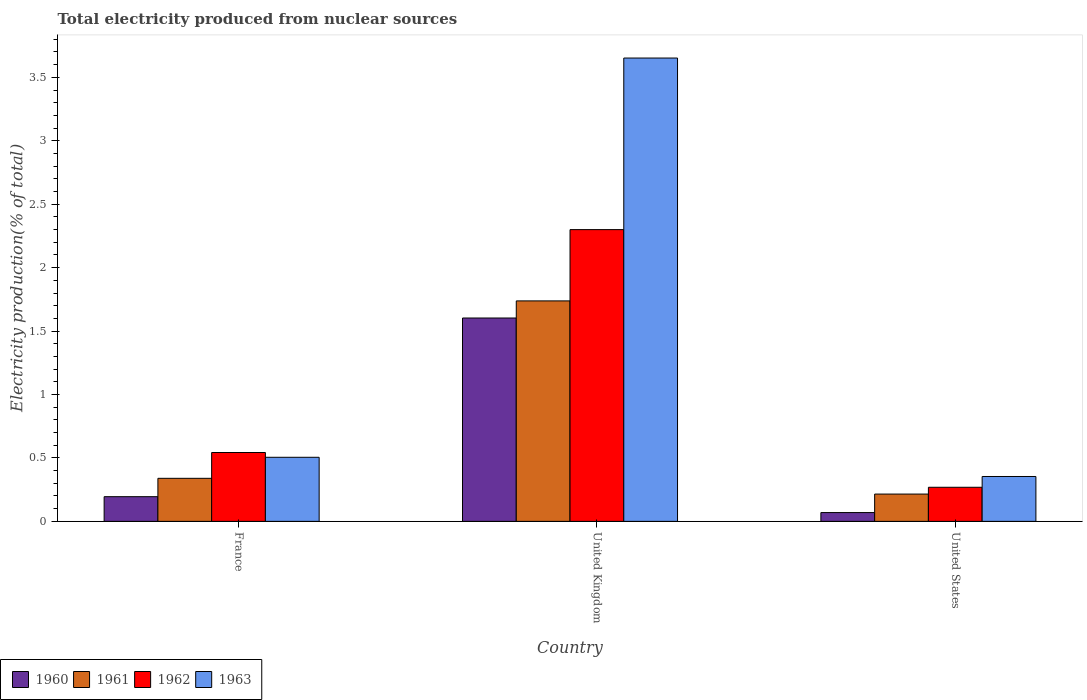How many bars are there on the 3rd tick from the left?
Make the answer very short. 4. In how many cases, is the number of bars for a given country not equal to the number of legend labels?
Provide a short and direct response. 0. What is the total electricity produced in 1960 in France?
Your answer should be compact. 0.19. Across all countries, what is the maximum total electricity produced in 1962?
Give a very brief answer. 2.3. Across all countries, what is the minimum total electricity produced in 1963?
Keep it short and to the point. 0.35. In which country was the total electricity produced in 1963 maximum?
Offer a very short reply. United Kingdom. In which country was the total electricity produced in 1962 minimum?
Make the answer very short. United States. What is the total total electricity produced in 1963 in the graph?
Ensure brevity in your answer.  4.51. What is the difference between the total electricity produced in 1962 in United Kingdom and that in United States?
Give a very brief answer. 2.03. What is the difference between the total electricity produced in 1960 in France and the total electricity produced in 1962 in United Kingdom?
Offer a terse response. -2.11. What is the average total electricity produced in 1960 per country?
Offer a terse response. 0.62. What is the difference between the total electricity produced of/in 1961 and total electricity produced of/in 1962 in France?
Offer a very short reply. -0.2. What is the ratio of the total electricity produced in 1960 in United Kingdom to that in United States?
Your answer should be compact. 23.14. Is the total electricity produced in 1960 in France less than that in United States?
Offer a very short reply. No. What is the difference between the highest and the second highest total electricity produced in 1963?
Give a very brief answer. -3.15. What is the difference between the highest and the lowest total electricity produced in 1960?
Your answer should be compact. 1.53. Is it the case that in every country, the sum of the total electricity produced in 1962 and total electricity produced in 1961 is greater than the sum of total electricity produced in 1960 and total electricity produced in 1963?
Your response must be concise. No. What does the 2nd bar from the left in United States represents?
Your response must be concise. 1961. What does the 1st bar from the right in United States represents?
Provide a succinct answer. 1963. Is it the case that in every country, the sum of the total electricity produced in 1962 and total electricity produced in 1963 is greater than the total electricity produced in 1961?
Ensure brevity in your answer.  Yes. Are all the bars in the graph horizontal?
Provide a succinct answer. No. Are the values on the major ticks of Y-axis written in scientific E-notation?
Provide a short and direct response. No. Does the graph contain any zero values?
Provide a short and direct response. No. Where does the legend appear in the graph?
Ensure brevity in your answer.  Bottom left. How many legend labels are there?
Your answer should be very brief. 4. What is the title of the graph?
Provide a short and direct response. Total electricity produced from nuclear sources. What is the Electricity production(% of total) of 1960 in France?
Make the answer very short. 0.19. What is the Electricity production(% of total) in 1961 in France?
Your answer should be compact. 0.34. What is the Electricity production(% of total) in 1962 in France?
Make the answer very short. 0.54. What is the Electricity production(% of total) of 1963 in France?
Provide a short and direct response. 0.51. What is the Electricity production(% of total) in 1960 in United Kingdom?
Give a very brief answer. 1.6. What is the Electricity production(% of total) of 1961 in United Kingdom?
Provide a succinct answer. 1.74. What is the Electricity production(% of total) of 1962 in United Kingdom?
Offer a very short reply. 2.3. What is the Electricity production(% of total) in 1963 in United Kingdom?
Provide a succinct answer. 3.65. What is the Electricity production(% of total) of 1960 in United States?
Your response must be concise. 0.07. What is the Electricity production(% of total) of 1961 in United States?
Keep it short and to the point. 0.22. What is the Electricity production(% of total) in 1962 in United States?
Provide a succinct answer. 0.27. What is the Electricity production(% of total) in 1963 in United States?
Make the answer very short. 0.35. Across all countries, what is the maximum Electricity production(% of total) of 1960?
Offer a very short reply. 1.6. Across all countries, what is the maximum Electricity production(% of total) of 1961?
Provide a short and direct response. 1.74. Across all countries, what is the maximum Electricity production(% of total) of 1962?
Your response must be concise. 2.3. Across all countries, what is the maximum Electricity production(% of total) in 1963?
Make the answer very short. 3.65. Across all countries, what is the minimum Electricity production(% of total) of 1960?
Give a very brief answer. 0.07. Across all countries, what is the minimum Electricity production(% of total) of 1961?
Your response must be concise. 0.22. Across all countries, what is the minimum Electricity production(% of total) in 1962?
Offer a terse response. 0.27. Across all countries, what is the minimum Electricity production(% of total) of 1963?
Provide a short and direct response. 0.35. What is the total Electricity production(% of total) in 1960 in the graph?
Your answer should be very brief. 1.87. What is the total Electricity production(% of total) of 1961 in the graph?
Provide a short and direct response. 2.29. What is the total Electricity production(% of total) of 1962 in the graph?
Your answer should be very brief. 3.11. What is the total Electricity production(% of total) in 1963 in the graph?
Keep it short and to the point. 4.51. What is the difference between the Electricity production(% of total) of 1960 in France and that in United Kingdom?
Give a very brief answer. -1.41. What is the difference between the Electricity production(% of total) of 1961 in France and that in United Kingdom?
Keep it short and to the point. -1.4. What is the difference between the Electricity production(% of total) in 1962 in France and that in United Kingdom?
Keep it short and to the point. -1.76. What is the difference between the Electricity production(% of total) of 1963 in France and that in United Kingdom?
Your response must be concise. -3.15. What is the difference between the Electricity production(% of total) of 1960 in France and that in United States?
Your answer should be very brief. 0.13. What is the difference between the Electricity production(% of total) in 1961 in France and that in United States?
Make the answer very short. 0.12. What is the difference between the Electricity production(% of total) in 1962 in France and that in United States?
Provide a short and direct response. 0.27. What is the difference between the Electricity production(% of total) of 1963 in France and that in United States?
Provide a succinct answer. 0.15. What is the difference between the Electricity production(% of total) in 1960 in United Kingdom and that in United States?
Make the answer very short. 1.53. What is the difference between the Electricity production(% of total) in 1961 in United Kingdom and that in United States?
Provide a succinct answer. 1.52. What is the difference between the Electricity production(% of total) of 1962 in United Kingdom and that in United States?
Give a very brief answer. 2.03. What is the difference between the Electricity production(% of total) in 1963 in United Kingdom and that in United States?
Ensure brevity in your answer.  3.3. What is the difference between the Electricity production(% of total) of 1960 in France and the Electricity production(% of total) of 1961 in United Kingdom?
Provide a short and direct response. -1.54. What is the difference between the Electricity production(% of total) in 1960 in France and the Electricity production(% of total) in 1962 in United Kingdom?
Your answer should be compact. -2.11. What is the difference between the Electricity production(% of total) in 1960 in France and the Electricity production(% of total) in 1963 in United Kingdom?
Give a very brief answer. -3.46. What is the difference between the Electricity production(% of total) of 1961 in France and the Electricity production(% of total) of 1962 in United Kingdom?
Provide a succinct answer. -1.96. What is the difference between the Electricity production(% of total) in 1961 in France and the Electricity production(% of total) in 1963 in United Kingdom?
Give a very brief answer. -3.31. What is the difference between the Electricity production(% of total) of 1962 in France and the Electricity production(% of total) of 1963 in United Kingdom?
Your answer should be very brief. -3.11. What is the difference between the Electricity production(% of total) in 1960 in France and the Electricity production(% of total) in 1961 in United States?
Your answer should be very brief. -0.02. What is the difference between the Electricity production(% of total) of 1960 in France and the Electricity production(% of total) of 1962 in United States?
Ensure brevity in your answer.  -0.07. What is the difference between the Electricity production(% of total) of 1960 in France and the Electricity production(% of total) of 1963 in United States?
Provide a short and direct response. -0.16. What is the difference between the Electricity production(% of total) of 1961 in France and the Electricity production(% of total) of 1962 in United States?
Your answer should be very brief. 0.07. What is the difference between the Electricity production(% of total) of 1961 in France and the Electricity production(% of total) of 1963 in United States?
Your answer should be compact. -0.01. What is the difference between the Electricity production(% of total) of 1962 in France and the Electricity production(% of total) of 1963 in United States?
Give a very brief answer. 0.19. What is the difference between the Electricity production(% of total) in 1960 in United Kingdom and the Electricity production(% of total) in 1961 in United States?
Give a very brief answer. 1.39. What is the difference between the Electricity production(% of total) in 1960 in United Kingdom and the Electricity production(% of total) in 1962 in United States?
Offer a very short reply. 1.33. What is the difference between the Electricity production(% of total) in 1960 in United Kingdom and the Electricity production(% of total) in 1963 in United States?
Make the answer very short. 1.25. What is the difference between the Electricity production(% of total) of 1961 in United Kingdom and the Electricity production(% of total) of 1962 in United States?
Your answer should be very brief. 1.47. What is the difference between the Electricity production(% of total) of 1961 in United Kingdom and the Electricity production(% of total) of 1963 in United States?
Offer a terse response. 1.38. What is the difference between the Electricity production(% of total) in 1962 in United Kingdom and the Electricity production(% of total) in 1963 in United States?
Offer a terse response. 1.95. What is the average Electricity production(% of total) of 1960 per country?
Keep it short and to the point. 0.62. What is the average Electricity production(% of total) of 1961 per country?
Give a very brief answer. 0.76. What is the average Electricity production(% of total) of 1962 per country?
Your answer should be very brief. 1.04. What is the average Electricity production(% of total) in 1963 per country?
Give a very brief answer. 1.5. What is the difference between the Electricity production(% of total) of 1960 and Electricity production(% of total) of 1961 in France?
Offer a terse response. -0.14. What is the difference between the Electricity production(% of total) of 1960 and Electricity production(% of total) of 1962 in France?
Keep it short and to the point. -0.35. What is the difference between the Electricity production(% of total) in 1960 and Electricity production(% of total) in 1963 in France?
Your response must be concise. -0.31. What is the difference between the Electricity production(% of total) of 1961 and Electricity production(% of total) of 1962 in France?
Make the answer very short. -0.2. What is the difference between the Electricity production(% of total) of 1961 and Electricity production(% of total) of 1963 in France?
Your response must be concise. -0.17. What is the difference between the Electricity production(% of total) of 1962 and Electricity production(% of total) of 1963 in France?
Ensure brevity in your answer.  0.04. What is the difference between the Electricity production(% of total) in 1960 and Electricity production(% of total) in 1961 in United Kingdom?
Provide a succinct answer. -0.13. What is the difference between the Electricity production(% of total) in 1960 and Electricity production(% of total) in 1962 in United Kingdom?
Give a very brief answer. -0.7. What is the difference between the Electricity production(% of total) of 1960 and Electricity production(% of total) of 1963 in United Kingdom?
Offer a very short reply. -2.05. What is the difference between the Electricity production(% of total) of 1961 and Electricity production(% of total) of 1962 in United Kingdom?
Your answer should be compact. -0.56. What is the difference between the Electricity production(% of total) in 1961 and Electricity production(% of total) in 1963 in United Kingdom?
Provide a succinct answer. -1.91. What is the difference between the Electricity production(% of total) in 1962 and Electricity production(% of total) in 1963 in United Kingdom?
Provide a short and direct response. -1.35. What is the difference between the Electricity production(% of total) in 1960 and Electricity production(% of total) in 1961 in United States?
Offer a terse response. -0.15. What is the difference between the Electricity production(% of total) in 1960 and Electricity production(% of total) in 1962 in United States?
Keep it short and to the point. -0.2. What is the difference between the Electricity production(% of total) of 1960 and Electricity production(% of total) of 1963 in United States?
Your response must be concise. -0.28. What is the difference between the Electricity production(% of total) of 1961 and Electricity production(% of total) of 1962 in United States?
Your answer should be very brief. -0.05. What is the difference between the Electricity production(% of total) in 1961 and Electricity production(% of total) in 1963 in United States?
Your answer should be very brief. -0.14. What is the difference between the Electricity production(% of total) in 1962 and Electricity production(% of total) in 1963 in United States?
Your response must be concise. -0.09. What is the ratio of the Electricity production(% of total) in 1960 in France to that in United Kingdom?
Offer a very short reply. 0.12. What is the ratio of the Electricity production(% of total) in 1961 in France to that in United Kingdom?
Provide a succinct answer. 0.2. What is the ratio of the Electricity production(% of total) in 1962 in France to that in United Kingdom?
Offer a very short reply. 0.24. What is the ratio of the Electricity production(% of total) of 1963 in France to that in United Kingdom?
Offer a terse response. 0.14. What is the ratio of the Electricity production(% of total) in 1960 in France to that in United States?
Offer a very short reply. 2.81. What is the ratio of the Electricity production(% of total) of 1961 in France to that in United States?
Your answer should be compact. 1.58. What is the ratio of the Electricity production(% of total) of 1962 in France to that in United States?
Offer a terse response. 2.02. What is the ratio of the Electricity production(% of total) in 1963 in France to that in United States?
Offer a very short reply. 1.43. What is the ratio of the Electricity production(% of total) in 1960 in United Kingdom to that in United States?
Provide a short and direct response. 23.14. What is the ratio of the Electricity production(% of total) of 1961 in United Kingdom to that in United States?
Offer a terse response. 8.08. What is the ratio of the Electricity production(% of total) in 1962 in United Kingdom to that in United States?
Ensure brevity in your answer.  8.56. What is the ratio of the Electricity production(% of total) in 1963 in United Kingdom to that in United States?
Make the answer very short. 10.32. What is the difference between the highest and the second highest Electricity production(% of total) of 1960?
Keep it short and to the point. 1.41. What is the difference between the highest and the second highest Electricity production(% of total) of 1961?
Keep it short and to the point. 1.4. What is the difference between the highest and the second highest Electricity production(% of total) in 1962?
Provide a short and direct response. 1.76. What is the difference between the highest and the second highest Electricity production(% of total) in 1963?
Provide a short and direct response. 3.15. What is the difference between the highest and the lowest Electricity production(% of total) in 1960?
Provide a short and direct response. 1.53. What is the difference between the highest and the lowest Electricity production(% of total) in 1961?
Provide a succinct answer. 1.52. What is the difference between the highest and the lowest Electricity production(% of total) of 1962?
Provide a short and direct response. 2.03. What is the difference between the highest and the lowest Electricity production(% of total) in 1963?
Provide a short and direct response. 3.3. 